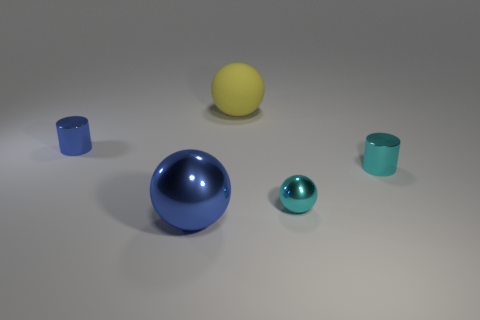Add 4 blue cylinders. How many objects exist? 9 Subtract all cylinders. How many objects are left? 3 Add 3 small balls. How many small balls exist? 4 Subtract 1 cyan cylinders. How many objects are left? 4 Subtract all cylinders. Subtract all tiny metallic cylinders. How many objects are left? 1 Add 5 shiny cylinders. How many shiny cylinders are left? 7 